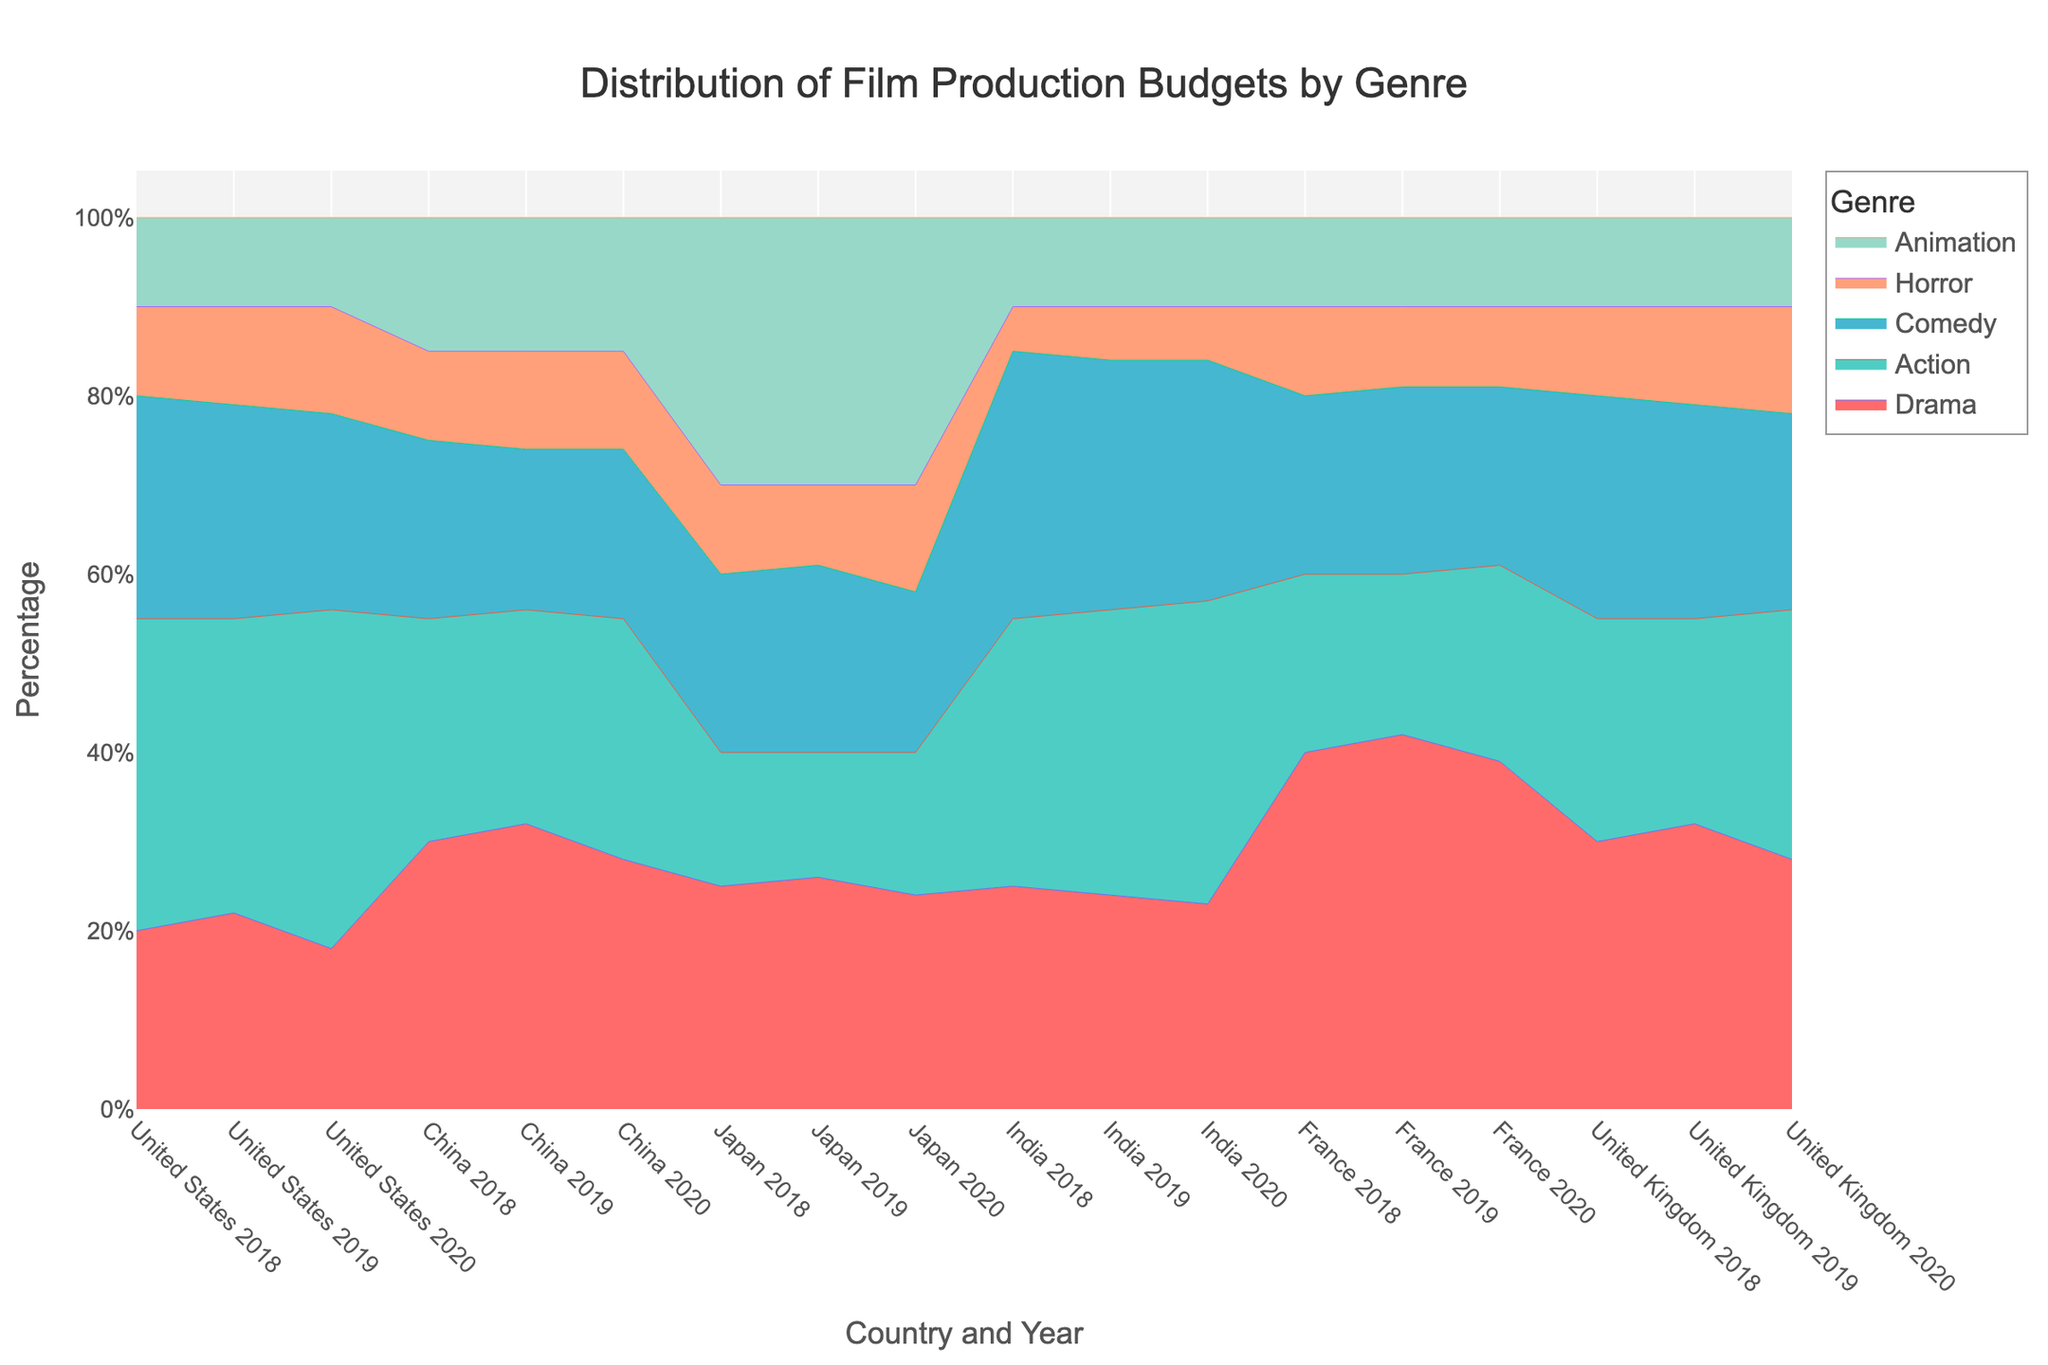Which country had the highest budget percentage for Drama in 2020? To determine the country with the highest budget percentage for Drama in 2020, observe the Drama portions of the 100% stacked area chart at the markers representing 2020. China shows the largest Drama segment for 2020.
Answer: China How did the percentage of Animation budget change in Japan from 2018 to 2020? Observe the Animation segments for Japan in 2018 and 2020. The Animation budget percentage consistently remains high at 30% for both 2018 and 2020.
Answer: No change Which genre had the least budget percentage in the United States in 2019? For the United States in 2019, examine the smallest segment in the stacked area chart. Horror, at 11%, is the smallest segment for that year.
Answer: Horror Comparing 2018 and 2020, which country's budget distribution for Action shows the most significant increase? Analyze the Action segments for all countries between 2018 and 2020. The United States' Action grew from 35% in 2018 to 38% in 2020, indicating the largest increase.
Answer: United States Is Comedy more prominent in India's film budget compared to the United Kingdom for 2020? Look at the Comedy segments in 2020 for both India and the United Kingdom. India's Comedy budget is larger at 27% compared to the United Kingdom's 22%.
Answer: Yes What's the total percentage of Horror budgets in all countries for 2018? Calculate the sum of Horror percentages for each country in 2018. United States (10%) + China (10%) + Japan (10%) + India (5%) + France (10%) + United Kingdom (10%) = 55%.
Answer: 55% Which country consistently spent 10% of its budget on Animation each year? Check the Animation segments for each year to find any country with consistent percentages. The United States shows 10% every year.
Answer: United States Did France spend more on Drama or Action in 2020? Compare the Drama and Action segments for France in 2020. France allocated 39% to Drama and 22% to Action.
Answer: Drama 